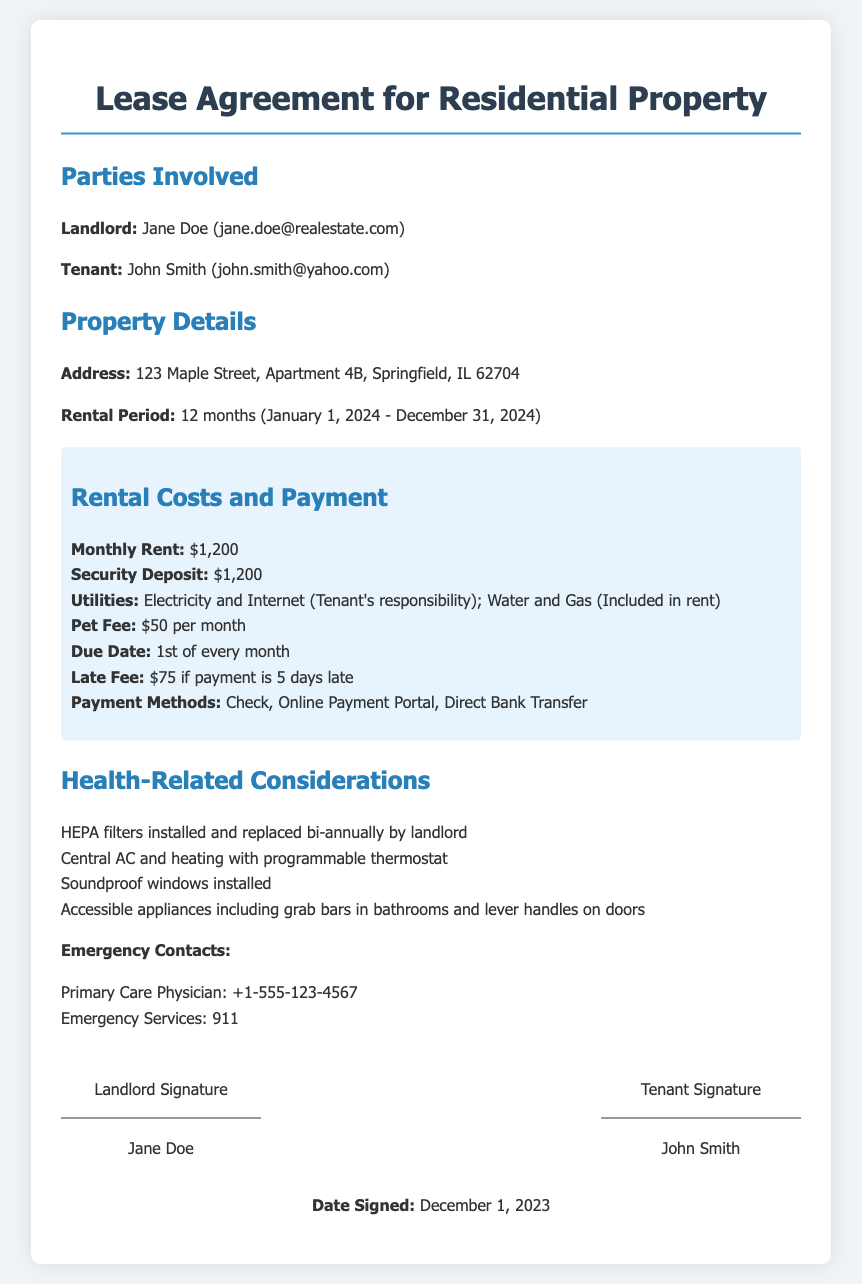what is the monthly rent? The monthly rent is specified in the rental costs section of the document.
Answer: $1,200 who is the landlord? The landlord's name is mentioned at the beginning of the document in the parties involved section.
Answer: Jane Doe what is the security deposit amount? The security deposit is mentioned in the rental costs section of the document.
Answer: $1,200 when does the rental period start? The start date of the rental period is detailed in the property details section.
Answer: January 1, 2024 what is the late fee amount? The late fee is stated in the rental costs section.
Answer: $75 how often are HEPA filters replaced? This is mentioned in the health-related considerations section of the document.
Answer: Bi-annually what is the pet fee per month? The pet fee is listed under the rental costs section.
Answer: $50 per month what is the due date for rent? The due date is specified in the rental costs section of the document.
Answer: 1st of every month who should be contacted for emergency services? This contact information is given in the health-related considerations section.
Answer: 911 